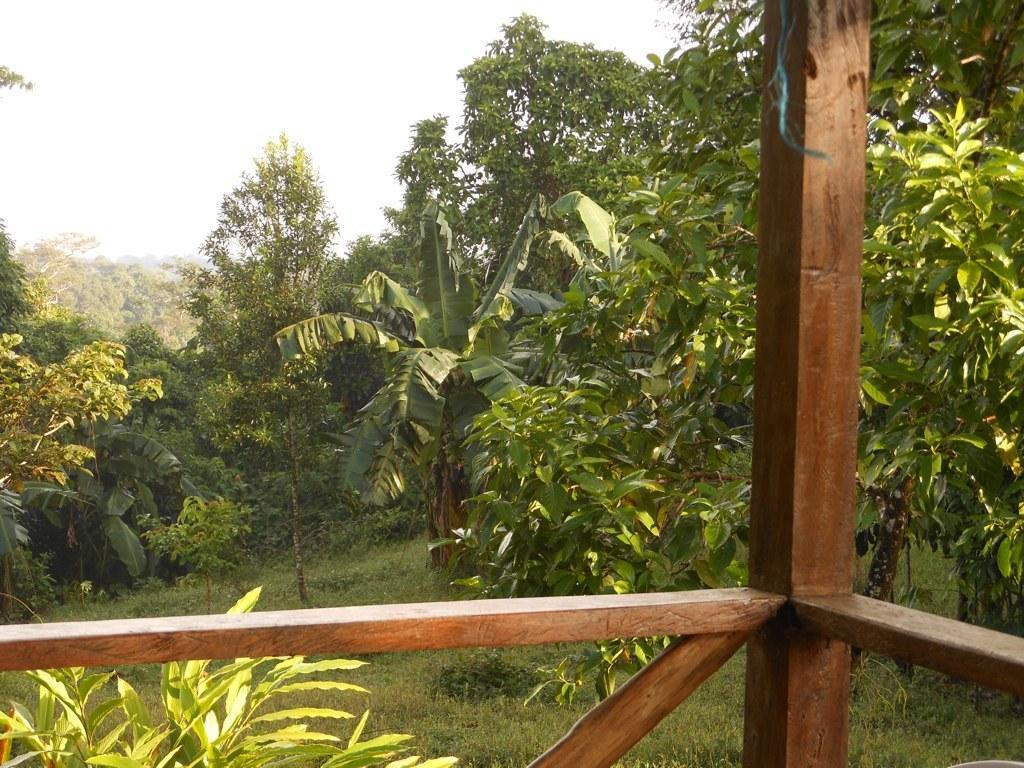Please provide a concise description of this image. At the bottom of the image we can see fencing. Behind the fencing we can see some trees and grass. At the top of the image we can see the sky. 